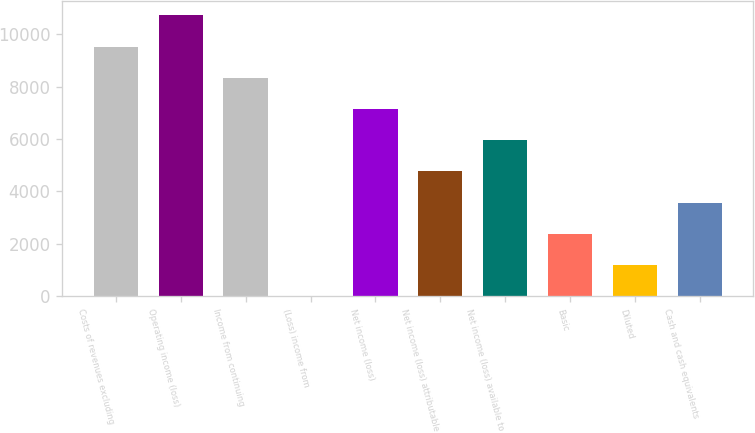Convert chart to OTSL. <chart><loc_0><loc_0><loc_500><loc_500><bar_chart><fcel>Costs of revenues excluding<fcel>Operating income (loss)<fcel>Income from continuing<fcel>(Loss) income from<fcel>Net income (loss)<fcel>Net income (loss) attributable<fcel>Net income (loss) available to<fcel>Basic<fcel>Diluted<fcel>Cash and cash equivalents<nl><fcel>9530.6<fcel>10721.8<fcel>8339.4<fcel>1<fcel>7148.2<fcel>4765.8<fcel>5957<fcel>2383.4<fcel>1192.2<fcel>3574.6<nl></chart> 